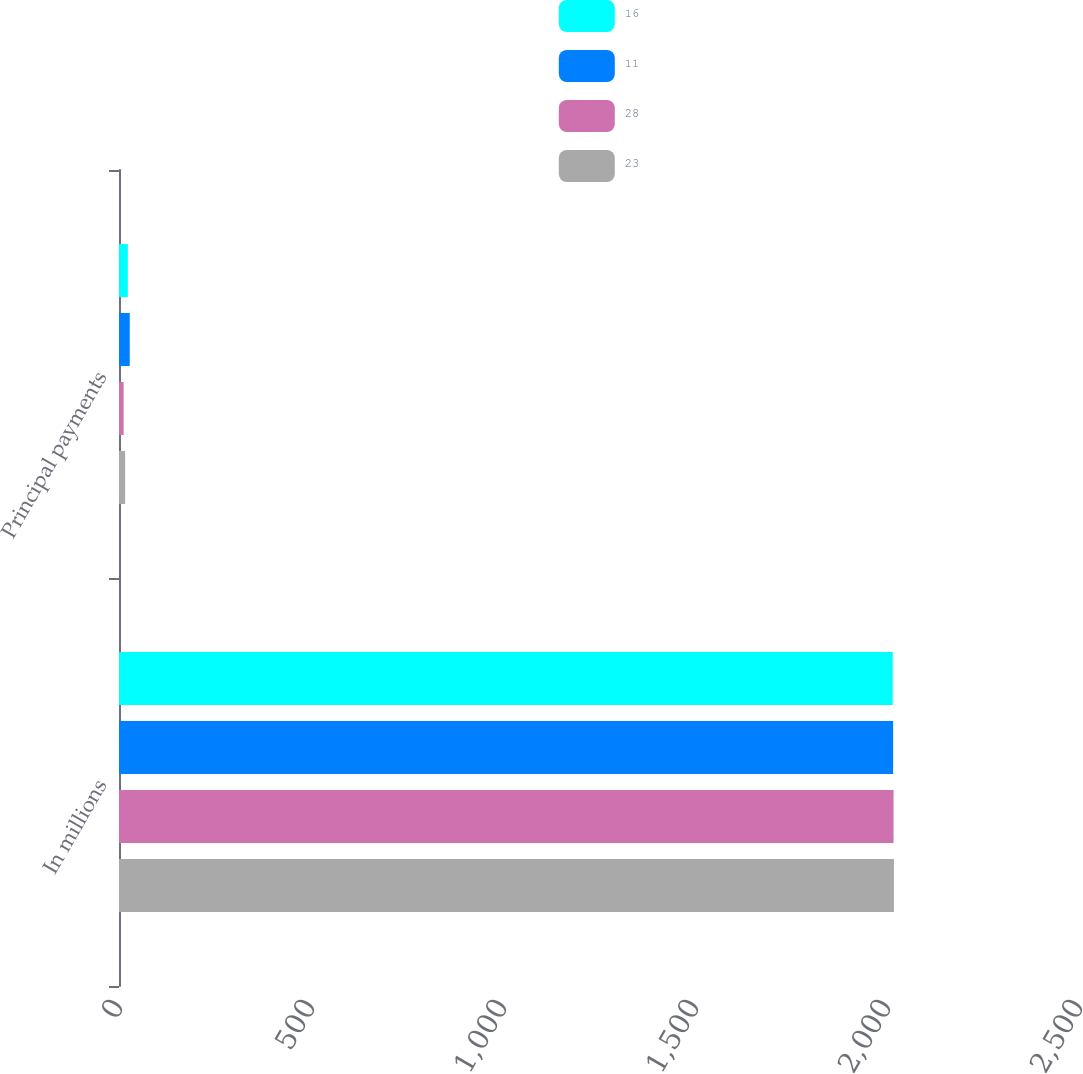Convert chart. <chart><loc_0><loc_0><loc_500><loc_500><stacked_bar_chart><ecel><fcel>In millions<fcel>Principal payments<nl><fcel>16<fcel>2015<fcel>23<nl><fcel>11<fcel>2016<fcel>28<nl><fcel>28<fcel>2017<fcel>12<nl><fcel>23<fcel>2018<fcel>16<nl></chart> 